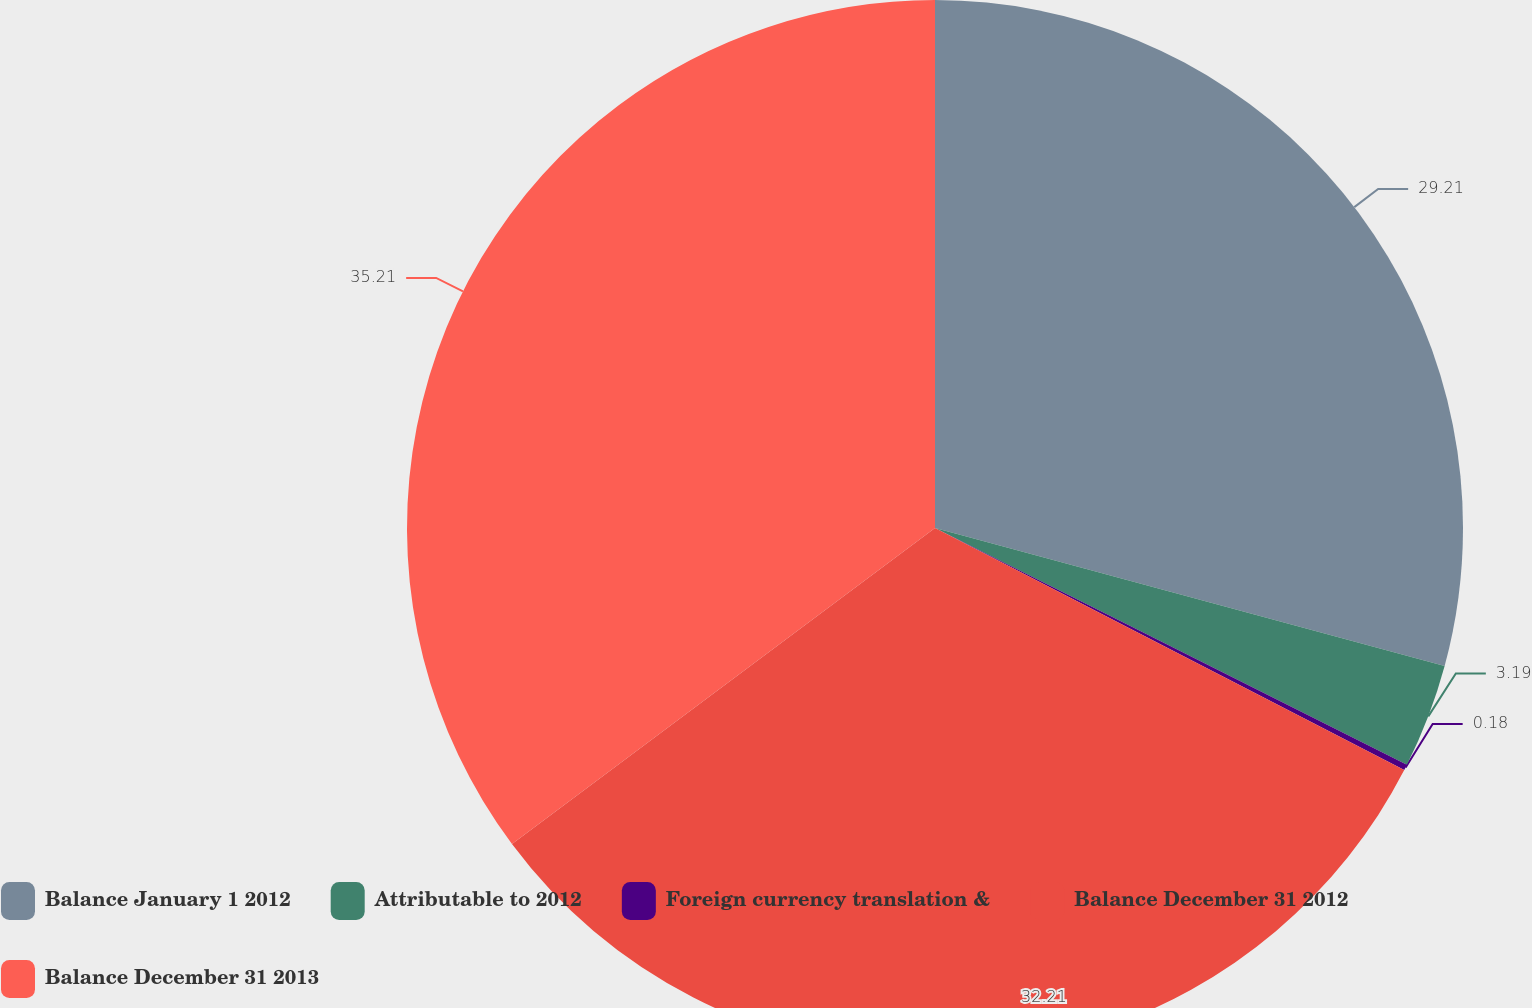Convert chart. <chart><loc_0><loc_0><loc_500><loc_500><pie_chart><fcel>Balance January 1 2012<fcel>Attributable to 2012<fcel>Foreign currency translation &<fcel>Balance December 31 2012<fcel>Balance December 31 2013<nl><fcel>29.21%<fcel>3.19%<fcel>0.18%<fcel>32.21%<fcel>35.21%<nl></chart> 